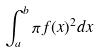<formula> <loc_0><loc_0><loc_500><loc_500>\int _ { a } ^ { b } \pi f ( x ) ^ { 2 } d x</formula> 